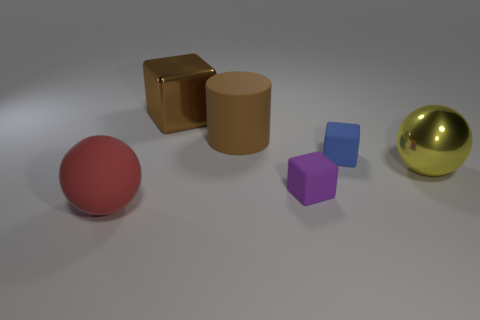Add 1 red objects. How many objects exist? 7 Subtract all cylinders. How many objects are left? 5 Add 3 big brown metallic things. How many big brown metallic things are left? 4 Add 5 small green metal cylinders. How many small green metal cylinders exist? 5 Subtract 0 green spheres. How many objects are left? 6 Subtract all yellow metal things. Subtract all brown objects. How many objects are left? 3 